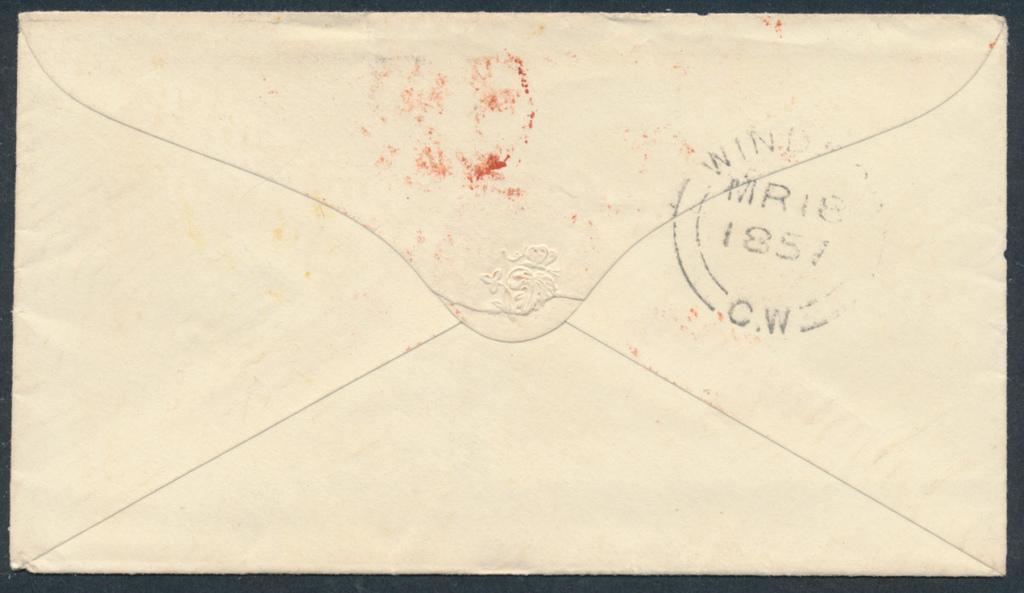<image>
Summarize the visual content of the image. the back of an envelope, the stamp nearly unreadable except for the year of 1857 